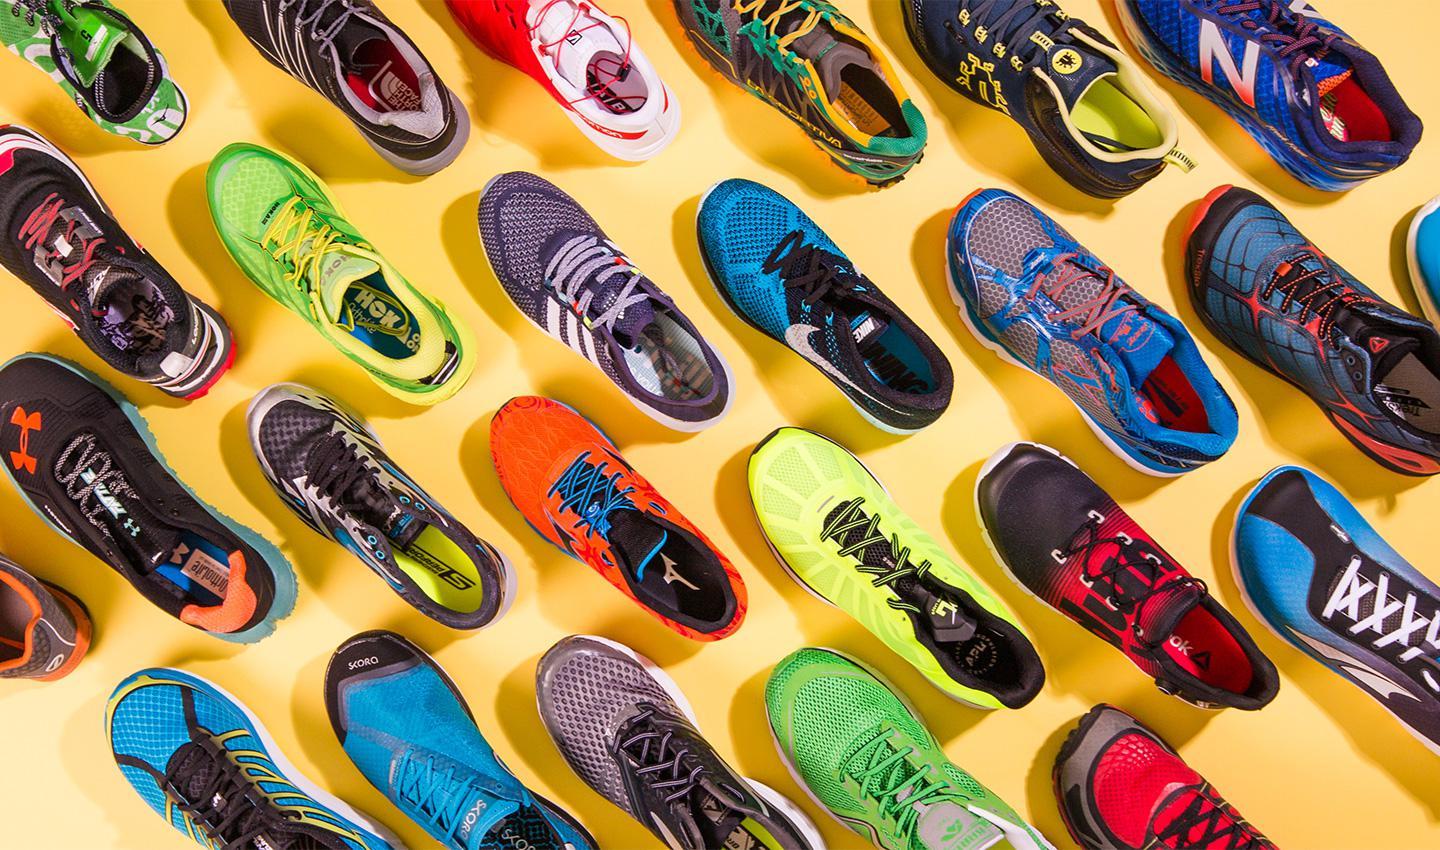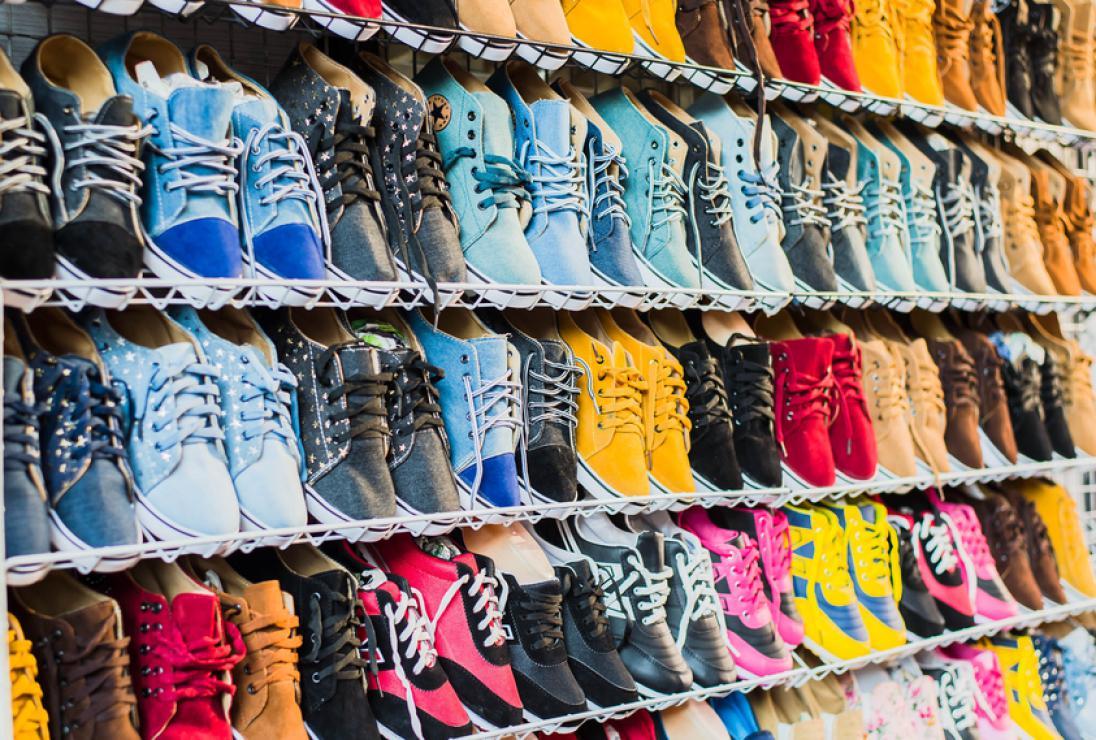The first image is the image on the left, the second image is the image on the right. Considering the images on both sides, is "A person is shown with at least one show in the image on the right." valid? Answer yes or no. No. The first image is the image on the left, the second image is the image on the right. For the images shown, is this caption "A human foot is present in an image with at least one sneaker also present." true? Answer yes or no. No. 